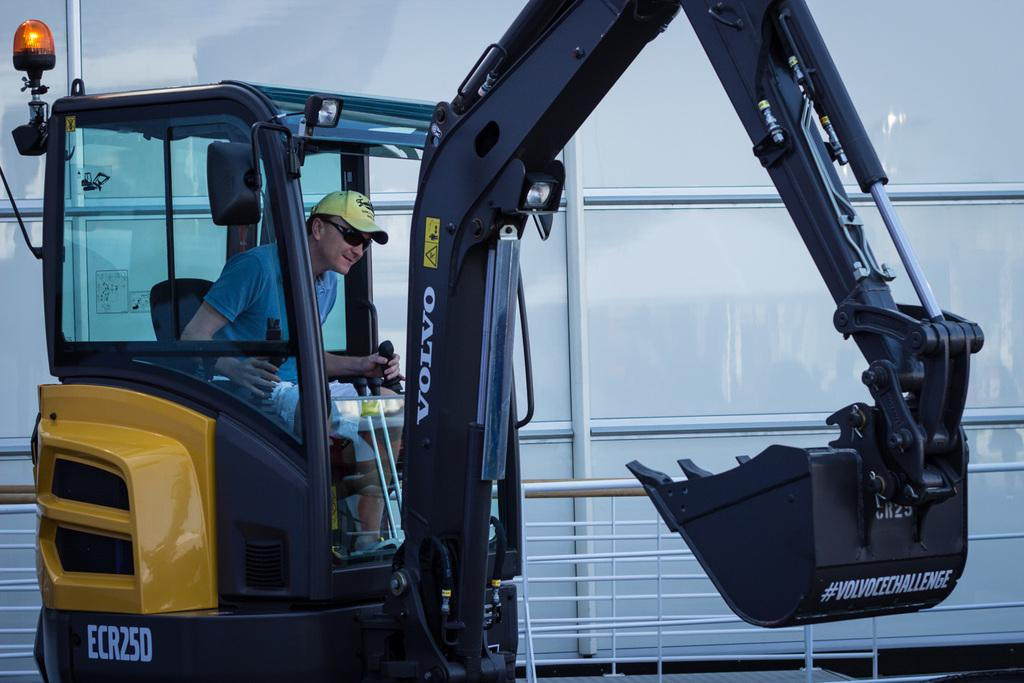What is the person in the image operating? The person is inside an excavator. What protective gear is the person wearing? The person is wearing goggles and a cap. Can you describe the lighting in the image? There is a light in the image. What objects can be seen in the background of the image? There are glasses and a fence in the background of the image. What type of paint is the rat using to draw on the excavator in the image? There is no rat or paint present in the image; it features a person operating an excavator. Is the person driving the excavator in the image? The image does not show the person driving the excavator, but rather operating it from inside the cab. 